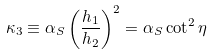Convert formula to latex. <formula><loc_0><loc_0><loc_500><loc_500>\kappa _ { 3 } \equiv \alpha _ { S } \left ( \frac { h _ { 1 } } { h _ { 2 } } \right ) ^ { 2 } = \alpha _ { S } \cot ^ { 2 } \eta</formula> 